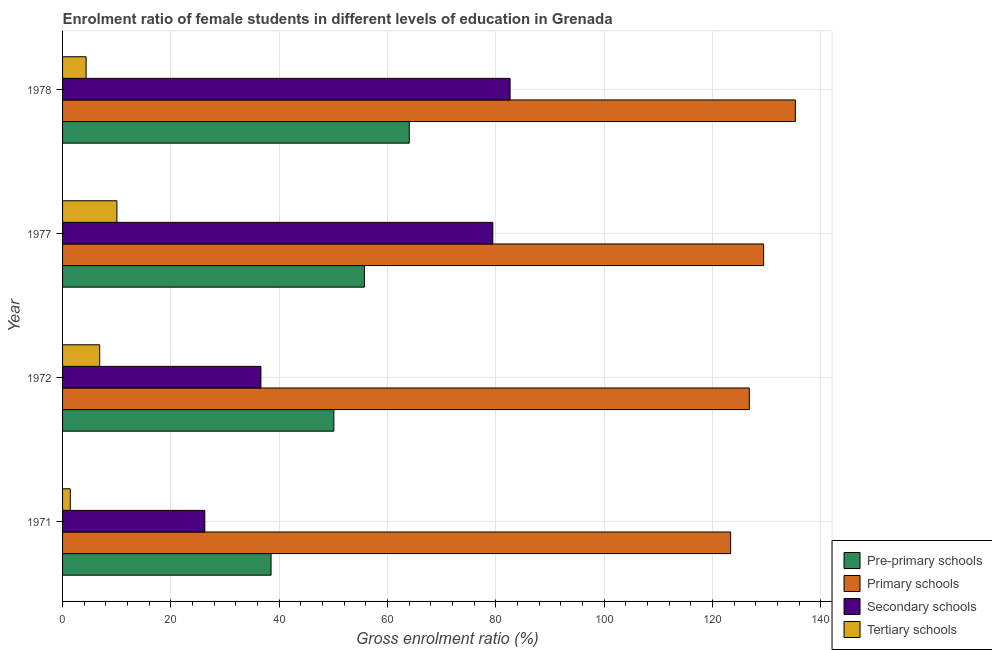How many different coloured bars are there?
Offer a terse response. 4. Are the number of bars per tick equal to the number of legend labels?
Offer a very short reply. Yes. What is the label of the 1st group of bars from the top?
Provide a short and direct response. 1978. In how many cases, is the number of bars for a given year not equal to the number of legend labels?
Offer a very short reply. 0. What is the gross enrolment ratio(male) in secondary schools in 1972?
Offer a terse response. 36.63. Across all years, what is the maximum gross enrolment ratio(male) in secondary schools?
Keep it short and to the point. 82.64. Across all years, what is the minimum gross enrolment ratio(male) in primary schools?
Give a very brief answer. 123.36. In which year was the gross enrolment ratio(male) in secondary schools maximum?
Provide a succinct answer. 1978. What is the total gross enrolment ratio(male) in secondary schools in the graph?
Your response must be concise. 224.98. What is the difference between the gross enrolment ratio(male) in tertiary schools in 1971 and that in 1977?
Give a very brief answer. -8.61. What is the difference between the gross enrolment ratio(male) in primary schools in 1971 and the gross enrolment ratio(male) in secondary schools in 1977?
Your answer should be compact. 43.92. What is the average gross enrolment ratio(male) in tertiary schools per year?
Your answer should be very brief. 5.67. In the year 1977, what is the difference between the gross enrolment ratio(male) in secondary schools and gross enrolment ratio(male) in pre-primary schools?
Make the answer very short. 23.71. In how many years, is the gross enrolment ratio(male) in tertiary schools greater than 116 %?
Offer a very short reply. 0. What is the ratio of the gross enrolment ratio(male) in pre-primary schools in 1972 to that in 1978?
Your answer should be very brief. 0.78. Is the gross enrolment ratio(male) in pre-primary schools in 1977 less than that in 1978?
Provide a short and direct response. Yes. What is the difference between the highest and the second highest gross enrolment ratio(male) in secondary schools?
Provide a short and direct response. 3.19. What is the difference between the highest and the lowest gross enrolment ratio(male) in secondary schools?
Make the answer very short. 56.37. What does the 2nd bar from the top in 1978 represents?
Offer a terse response. Secondary schools. What does the 2nd bar from the bottom in 1978 represents?
Give a very brief answer. Primary schools. Is it the case that in every year, the sum of the gross enrolment ratio(male) in pre-primary schools and gross enrolment ratio(male) in primary schools is greater than the gross enrolment ratio(male) in secondary schools?
Your answer should be compact. Yes. How many bars are there?
Provide a short and direct response. 16. Are all the bars in the graph horizontal?
Provide a short and direct response. Yes. How many years are there in the graph?
Provide a succinct answer. 4. Does the graph contain grids?
Offer a terse response. Yes. Where does the legend appear in the graph?
Give a very brief answer. Bottom right. How are the legend labels stacked?
Provide a short and direct response. Vertical. What is the title of the graph?
Your answer should be compact. Enrolment ratio of female students in different levels of education in Grenada. Does "Mammal species" appear as one of the legend labels in the graph?
Ensure brevity in your answer.  No. What is the Gross enrolment ratio (%) in Pre-primary schools in 1971?
Provide a succinct answer. 38.5. What is the Gross enrolment ratio (%) of Primary schools in 1971?
Offer a terse response. 123.36. What is the Gross enrolment ratio (%) in Secondary schools in 1971?
Your answer should be very brief. 26.27. What is the Gross enrolment ratio (%) in Tertiary schools in 1971?
Your answer should be compact. 1.42. What is the Gross enrolment ratio (%) in Pre-primary schools in 1972?
Your response must be concise. 50.09. What is the Gross enrolment ratio (%) of Primary schools in 1972?
Your answer should be very brief. 126.81. What is the Gross enrolment ratio (%) of Secondary schools in 1972?
Give a very brief answer. 36.63. What is the Gross enrolment ratio (%) in Tertiary schools in 1972?
Offer a very short reply. 6.85. What is the Gross enrolment ratio (%) of Pre-primary schools in 1977?
Your answer should be compact. 55.73. What is the Gross enrolment ratio (%) of Primary schools in 1977?
Your answer should be very brief. 129.45. What is the Gross enrolment ratio (%) of Secondary schools in 1977?
Keep it short and to the point. 79.45. What is the Gross enrolment ratio (%) of Tertiary schools in 1977?
Provide a succinct answer. 10.03. What is the Gross enrolment ratio (%) in Pre-primary schools in 1978?
Your answer should be very brief. 64.02. What is the Gross enrolment ratio (%) in Primary schools in 1978?
Keep it short and to the point. 135.32. What is the Gross enrolment ratio (%) of Secondary schools in 1978?
Provide a short and direct response. 82.64. What is the Gross enrolment ratio (%) in Tertiary schools in 1978?
Make the answer very short. 4.35. Across all years, what is the maximum Gross enrolment ratio (%) in Pre-primary schools?
Your response must be concise. 64.02. Across all years, what is the maximum Gross enrolment ratio (%) in Primary schools?
Offer a very short reply. 135.32. Across all years, what is the maximum Gross enrolment ratio (%) in Secondary schools?
Give a very brief answer. 82.64. Across all years, what is the maximum Gross enrolment ratio (%) in Tertiary schools?
Provide a short and direct response. 10.03. Across all years, what is the minimum Gross enrolment ratio (%) in Pre-primary schools?
Provide a short and direct response. 38.5. Across all years, what is the minimum Gross enrolment ratio (%) of Primary schools?
Your response must be concise. 123.36. Across all years, what is the minimum Gross enrolment ratio (%) of Secondary schools?
Your answer should be very brief. 26.27. Across all years, what is the minimum Gross enrolment ratio (%) in Tertiary schools?
Your response must be concise. 1.42. What is the total Gross enrolment ratio (%) of Pre-primary schools in the graph?
Ensure brevity in your answer.  208.35. What is the total Gross enrolment ratio (%) in Primary schools in the graph?
Ensure brevity in your answer.  514.95. What is the total Gross enrolment ratio (%) in Secondary schools in the graph?
Your response must be concise. 224.98. What is the total Gross enrolment ratio (%) of Tertiary schools in the graph?
Give a very brief answer. 22.66. What is the difference between the Gross enrolment ratio (%) of Pre-primary schools in 1971 and that in 1972?
Ensure brevity in your answer.  -11.59. What is the difference between the Gross enrolment ratio (%) of Primary schools in 1971 and that in 1972?
Ensure brevity in your answer.  -3.45. What is the difference between the Gross enrolment ratio (%) of Secondary schools in 1971 and that in 1972?
Your answer should be compact. -10.36. What is the difference between the Gross enrolment ratio (%) in Tertiary schools in 1971 and that in 1972?
Offer a terse response. -5.43. What is the difference between the Gross enrolment ratio (%) of Pre-primary schools in 1971 and that in 1977?
Offer a terse response. -17.23. What is the difference between the Gross enrolment ratio (%) of Primary schools in 1971 and that in 1977?
Keep it short and to the point. -6.09. What is the difference between the Gross enrolment ratio (%) of Secondary schools in 1971 and that in 1977?
Make the answer very short. -53.18. What is the difference between the Gross enrolment ratio (%) of Tertiary schools in 1971 and that in 1977?
Offer a terse response. -8.61. What is the difference between the Gross enrolment ratio (%) in Pre-primary schools in 1971 and that in 1978?
Ensure brevity in your answer.  -25.52. What is the difference between the Gross enrolment ratio (%) in Primary schools in 1971 and that in 1978?
Provide a short and direct response. -11.96. What is the difference between the Gross enrolment ratio (%) of Secondary schools in 1971 and that in 1978?
Offer a terse response. -56.37. What is the difference between the Gross enrolment ratio (%) in Tertiary schools in 1971 and that in 1978?
Provide a succinct answer. -2.92. What is the difference between the Gross enrolment ratio (%) in Pre-primary schools in 1972 and that in 1977?
Your answer should be very brief. -5.64. What is the difference between the Gross enrolment ratio (%) of Primary schools in 1972 and that in 1977?
Your answer should be very brief. -2.64. What is the difference between the Gross enrolment ratio (%) of Secondary schools in 1972 and that in 1977?
Offer a very short reply. -42.82. What is the difference between the Gross enrolment ratio (%) in Tertiary schools in 1972 and that in 1977?
Keep it short and to the point. -3.18. What is the difference between the Gross enrolment ratio (%) in Pre-primary schools in 1972 and that in 1978?
Make the answer very short. -13.93. What is the difference between the Gross enrolment ratio (%) in Primary schools in 1972 and that in 1978?
Your response must be concise. -8.51. What is the difference between the Gross enrolment ratio (%) of Secondary schools in 1972 and that in 1978?
Keep it short and to the point. -46.01. What is the difference between the Gross enrolment ratio (%) in Tertiary schools in 1972 and that in 1978?
Ensure brevity in your answer.  2.51. What is the difference between the Gross enrolment ratio (%) of Pre-primary schools in 1977 and that in 1978?
Keep it short and to the point. -8.29. What is the difference between the Gross enrolment ratio (%) in Primary schools in 1977 and that in 1978?
Provide a succinct answer. -5.87. What is the difference between the Gross enrolment ratio (%) of Secondary schools in 1977 and that in 1978?
Keep it short and to the point. -3.19. What is the difference between the Gross enrolment ratio (%) of Tertiary schools in 1977 and that in 1978?
Offer a terse response. 5.69. What is the difference between the Gross enrolment ratio (%) of Pre-primary schools in 1971 and the Gross enrolment ratio (%) of Primary schools in 1972?
Provide a succinct answer. -88.31. What is the difference between the Gross enrolment ratio (%) in Pre-primary schools in 1971 and the Gross enrolment ratio (%) in Secondary schools in 1972?
Your answer should be very brief. 1.87. What is the difference between the Gross enrolment ratio (%) in Pre-primary schools in 1971 and the Gross enrolment ratio (%) in Tertiary schools in 1972?
Your answer should be compact. 31.65. What is the difference between the Gross enrolment ratio (%) of Primary schools in 1971 and the Gross enrolment ratio (%) of Secondary schools in 1972?
Ensure brevity in your answer.  86.74. What is the difference between the Gross enrolment ratio (%) in Primary schools in 1971 and the Gross enrolment ratio (%) in Tertiary schools in 1972?
Your answer should be compact. 116.51. What is the difference between the Gross enrolment ratio (%) in Secondary schools in 1971 and the Gross enrolment ratio (%) in Tertiary schools in 1972?
Your answer should be compact. 19.41. What is the difference between the Gross enrolment ratio (%) in Pre-primary schools in 1971 and the Gross enrolment ratio (%) in Primary schools in 1977?
Offer a terse response. -90.95. What is the difference between the Gross enrolment ratio (%) in Pre-primary schools in 1971 and the Gross enrolment ratio (%) in Secondary schools in 1977?
Your response must be concise. -40.95. What is the difference between the Gross enrolment ratio (%) in Pre-primary schools in 1971 and the Gross enrolment ratio (%) in Tertiary schools in 1977?
Make the answer very short. 28.47. What is the difference between the Gross enrolment ratio (%) in Primary schools in 1971 and the Gross enrolment ratio (%) in Secondary schools in 1977?
Offer a very short reply. 43.92. What is the difference between the Gross enrolment ratio (%) of Primary schools in 1971 and the Gross enrolment ratio (%) of Tertiary schools in 1977?
Your response must be concise. 113.33. What is the difference between the Gross enrolment ratio (%) of Secondary schools in 1971 and the Gross enrolment ratio (%) of Tertiary schools in 1977?
Provide a short and direct response. 16.23. What is the difference between the Gross enrolment ratio (%) in Pre-primary schools in 1971 and the Gross enrolment ratio (%) in Primary schools in 1978?
Keep it short and to the point. -96.82. What is the difference between the Gross enrolment ratio (%) in Pre-primary schools in 1971 and the Gross enrolment ratio (%) in Secondary schools in 1978?
Your answer should be very brief. -44.14. What is the difference between the Gross enrolment ratio (%) in Pre-primary schools in 1971 and the Gross enrolment ratio (%) in Tertiary schools in 1978?
Ensure brevity in your answer.  34.15. What is the difference between the Gross enrolment ratio (%) in Primary schools in 1971 and the Gross enrolment ratio (%) in Secondary schools in 1978?
Ensure brevity in your answer.  40.73. What is the difference between the Gross enrolment ratio (%) of Primary schools in 1971 and the Gross enrolment ratio (%) of Tertiary schools in 1978?
Your answer should be compact. 119.02. What is the difference between the Gross enrolment ratio (%) in Secondary schools in 1971 and the Gross enrolment ratio (%) in Tertiary schools in 1978?
Your answer should be compact. 21.92. What is the difference between the Gross enrolment ratio (%) in Pre-primary schools in 1972 and the Gross enrolment ratio (%) in Primary schools in 1977?
Your answer should be very brief. -79.36. What is the difference between the Gross enrolment ratio (%) in Pre-primary schools in 1972 and the Gross enrolment ratio (%) in Secondary schools in 1977?
Provide a short and direct response. -29.35. What is the difference between the Gross enrolment ratio (%) in Pre-primary schools in 1972 and the Gross enrolment ratio (%) in Tertiary schools in 1977?
Offer a terse response. 40.06. What is the difference between the Gross enrolment ratio (%) in Primary schools in 1972 and the Gross enrolment ratio (%) in Secondary schools in 1977?
Your answer should be compact. 47.36. What is the difference between the Gross enrolment ratio (%) in Primary schools in 1972 and the Gross enrolment ratio (%) in Tertiary schools in 1977?
Provide a short and direct response. 116.78. What is the difference between the Gross enrolment ratio (%) in Secondary schools in 1972 and the Gross enrolment ratio (%) in Tertiary schools in 1977?
Offer a very short reply. 26.59. What is the difference between the Gross enrolment ratio (%) of Pre-primary schools in 1972 and the Gross enrolment ratio (%) of Primary schools in 1978?
Provide a short and direct response. -85.23. What is the difference between the Gross enrolment ratio (%) of Pre-primary schools in 1972 and the Gross enrolment ratio (%) of Secondary schools in 1978?
Offer a terse response. -32.54. What is the difference between the Gross enrolment ratio (%) in Pre-primary schools in 1972 and the Gross enrolment ratio (%) in Tertiary schools in 1978?
Offer a terse response. 45.75. What is the difference between the Gross enrolment ratio (%) in Primary schools in 1972 and the Gross enrolment ratio (%) in Secondary schools in 1978?
Offer a terse response. 44.17. What is the difference between the Gross enrolment ratio (%) of Primary schools in 1972 and the Gross enrolment ratio (%) of Tertiary schools in 1978?
Make the answer very short. 122.47. What is the difference between the Gross enrolment ratio (%) of Secondary schools in 1972 and the Gross enrolment ratio (%) of Tertiary schools in 1978?
Provide a short and direct response. 32.28. What is the difference between the Gross enrolment ratio (%) of Pre-primary schools in 1977 and the Gross enrolment ratio (%) of Primary schools in 1978?
Keep it short and to the point. -79.59. What is the difference between the Gross enrolment ratio (%) of Pre-primary schools in 1977 and the Gross enrolment ratio (%) of Secondary schools in 1978?
Make the answer very short. -26.91. What is the difference between the Gross enrolment ratio (%) in Pre-primary schools in 1977 and the Gross enrolment ratio (%) in Tertiary schools in 1978?
Your answer should be very brief. 51.39. What is the difference between the Gross enrolment ratio (%) in Primary schools in 1977 and the Gross enrolment ratio (%) in Secondary schools in 1978?
Your answer should be compact. 46.82. What is the difference between the Gross enrolment ratio (%) of Primary schools in 1977 and the Gross enrolment ratio (%) of Tertiary schools in 1978?
Offer a very short reply. 125.11. What is the difference between the Gross enrolment ratio (%) of Secondary schools in 1977 and the Gross enrolment ratio (%) of Tertiary schools in 1978?
Keep it short and to the point. 75.1. What is the average Gross enrolment ratio (%) in Pre-primary schools per year?
Provide a succinct answer. 52.09. What is the average Gross enrolment ratio (%) in Primary schools per year?
Give a very brief answer. 128.74. What is the average Gross enrolment ratio (%) of Secondary schools per year?
Provide a succinct answer. 56.24. What is the average Gross enrolment ratio (%) in Tertiary schools per year?
Offer a terse response. 5.66. In the year 1971, what is the difference between the Gross enrolment ratio (%) in Pre-primary schools and Gross enrolment ratio (%) in Primary schools?
Your answer should be very brief. -84.86. In the year 1971, what is the difference between the Gross enrolment ratio (%) of Pre-primary schools and Gross enrolment ratio (%) of Secondary schools?
Your answer should be very brief. 12.24. In the year 1971, what is the difference between the Gross enrolment ratio (%) of Pre-primary schools and Gross enrolment ratio (%) of Tertiary schools?
Offer a terse response. 37.08. In the year 1971, what is the difference between the Gross enrolment ratio (%) of Primary schools and Gross enrolment ratio (%) of Secondary schools?
Your answer should be very brief. 97.1. In the year 1971, what is the difference between the Gross enrolment ratio (%) in Primary schools and Gross enrolment ratio (%) in Tertiary schools?
Ensure brevity in your answer.  121.94. In the year 1971, what is the difference between the Gross enrolment ratio (%) of Secondary schools and Gross enrolment ratio (%) of Tertiary schools?
Keep it short and to the point. 24.84. In the year 1972, what is the difference between the Gross enrolment ratio (%) in Pre-primary schools and Gross enrolment ratio (%) in Primary schools?
Provide a short and direct response. -76.72. In the year 1972, what is the difference between the Gross enrolment ratio (%) in Pre-primary schools and Gross enrolment ratio (%) in Secondary schools?
Your answer should be compact. 13.47. In the year 1972, what is the difference between the Gross enrolment ratio (%) of Pre-primary schools and Gross enrolment ratio (%) of Tertiary schools?
Make the answer very short. 43.24. In the year 1972, what is the difference between the Gross enrolment ratio (%) of Primary schools and Gross enrolment ratio (%) of Secondary schools?
Your answer should be compact. 90.19. In the year 1972, what is the difference between the Gross enrolment ratio (%) of Primary schools and Gross enrolment ratio (%) of Tertiary schools?
Make the answer very short. 119.96. In the year 1972, what is the difference between the Gross enrolment ratio (%) of Secondary schools and Gross enrolment ratio (%) of Tertiary schools?
Keep it short and to the point. 29.77. In the year 1977, what is the difference between the Gross enrolment ratio (%) of Pre-primary schools and Gross enrolment ratio (%) of Primary schools?
Your answer should be compact. -73.72. In the year 1977, what is the difference between the Gross enrolment ratio (%) of Pre-primary schools and Gross enrolment ratio (%) of Secondary schools?
Provide a short and direct response. -23.72. In the year 1977, what is the difference between the Gross enrolment ratio (%) in Pre-primary schools and Gross enrolment ratio (%) in Tertiary schools?
Offer a very short reply. 45.7. In the year 1977, what is the difference between the Gross enrolment ratio (%) in Primary schools and Gross enrolment ratio (%) in Secondary schools?
Your answer should be compact. 50.01. In the year 1977, what is the difference between the Gross enrolment ratio (%) in Primary schools and Gross enrolment ratio (%) in Tertiary schools?
Provide a short and direct response. 119.42. In the year 1977, what is the difference between the Gross enrolment ratio (%) of Secondary schools and Gross enrolment ratio (%) of Tertiary schools?
Offer a terse response. 69.41. In the year 1978, what is the difference between the Gross enrolment ratio (%) of Pre-primary schools and Gross enrolment ratio (%) of Primary schools?
Give a very brief answer. -71.3. In the year 1978, what is the difference between the Gross enrolment ratio (%) in Pre-primary schools and Gross enrolment ratio (%) in Secondary schools?
Make the answer very short. -18.62. In the year 1978, what is the difference between the Gross enrolment ratio (%) in Pre-primary schools and Gross enrolment ratio (%) in Tertiary schools?
Your answer should be compact. 59.67. In the year 1978, what is the difference between the Gross enrolment ratio (%) in Primary schools and Gross enrolment ratio (%) in Secondary schools?
Give a very brief answer. 52.68. In the year 1978, what is the difference between the Gross enrolment ratio (%) in Primary schools and Gross enrolment ratio (%) in Tertiary schools?
Your answer should be compact. 130.97. In the year 1978, what is the difference between the Gross enrolment ratio (%) of Secondary schools and Gross enrolment ratio (%) of Tertiary schools?
Provide a succinct answer. 78.29. What is the ratio of the Gross enrolment ratio (%) in Pre-primary schools in 1971 to that in 1972?
Offer a terse response. 0.77. What is the ratio of the Gross enrolment ratio (%) of Primary schools in 1971 to that in 1972?
Ensure brevity in your answer.  0.97. What is the ratio of the Gross enrolment ratio (%) of Secondary schools in 1971 to that in 1972?
Your response must be concise. 0.72. What is the ratio of the Gross enrolment ratio (%) in Tertiary schools in 1971 to that in 1972?
Make the answer very short. 0.21. What is the ratio of the Gross enrolment ratio (%) in Pre-primary schools in 1971 to that in 1977?
Keep it short and to the point. 0.69. What is the ratio of the Gross enrolment ratio (%) of Primary schools in 1971 to that in 1977?
Provide a short and direct response. 0.95. What is the ratio of the Gross enrolment ratio (%) in Secondary schools in 1971 to that in 1977?
Your answer should be compact. 0.33. What is the ratio of the Gross enrolment ratio (%) in Tertiary schools in 1971 to that in 1977?
Provide a succinct answer. 0.14. What is the ratio of the Gross enrolment ratio (%) in Pre-primary schools in 1971 to that in 1978?
Offer a terse response. 0.6. What is the ratio of the Gross enrolment ratio (%) of Primary schools in 1971 to that in 1978?
Offer a terse response. 0.91. What is the ratio of the Gross enrolment ratio (%) in Secondary schools in 1971 to that in 1978?
Keep it short and to the point. 0.32. What is the ratio of the Gross enrolment ratio (%) of Tertiary schools in 1971 to that in 1978?
Make the answer very short. 0.33. What is the ratio of the Gross enrolment ratio (%) in Pre-primary schools in 1972 to that in 1977?
Provide a short and direct response. 0.9. What is the ratio of the Gross enrolment ratio (%) in Primary schools in 1972 to that in 1977?
Your answer should be very brief. 0.98. What is the ratio of the Gross enrolment ratio (%) in Secondary schools in 1972 to that in 1977?
Offer a terse response. 0.46. What is the ratio of the Gross enrolment ratio (%) of Tertiary schools in 1972 to that in 1977?
Your response must be concise. 0.68. What is the ratio of the Gross enrolment ratio (%) in Pre-primary schools in 1972 to that in 1978?
Ensure brevity in your answer.  0.78. What is the ratio of the Gross enrolment ratio (%) in Primary schools in 1972 to that in 1978?
Keep it short and to the point. 0.94. What is the ratio of the Gross enrolment ratio (%) of Secondary schools in 1972 to that in 1978?
Keep it short and to the point. 0.44. What is the ratio of the Gross enrolment ratio (%) of Tertiary schools in 1972 to that in 1978?
Offer a terse response. 1.58. What is the ratio of the Gross enrolment ratio (%) in Pre-primary schools in 1977 to that in 1978?
Offer a very short reply. 0.87. What is the ratio of the Gross enrolment ratio (%) in Primary schools in 1977 to that in 1978?
Provide a succinct answer. 0.96. What is the ratio of the Gross enrolment ratio (%) of Secondary schools in 1977 to that in 1978?
Your response must be concise. 0.96. What is the ratio of the Gross enrolment ratio (%) of Tertiary schools in 1977 to that in 1978?
Keep it short and to the point. 2.31. What is the difference between the highest and the second highest Gross enrolment ratio (%) of Pre-primary schools?
Your answer should be very brief. 8.29. What is the difference between the highest and the second highest Gross enrolment ratio (%) of Primary schools?
Make the answer very short. 5.87. What is the difference between the highest and the second highest Gross enrolment ratio (%) in Secondary schools?
Your answer should be compact. 3.19. What is the difference between the highest and the second highest Gross enrolment ratio (%) of Tertiary schools?
Provide a short and direct response. 3.18. What is the difference between the highest and the lowest Gross enrolment ratio (%) of Pre-primary schools?
Keep it short and to the point. 25.52. What is the difference between the highest and the lowest Gross enrolment ratio (%) of Primary schools?
Offer a terse response. 11.96. What is the difference between the highest and the lowest Gross enrolment ratio (%) in Secondary schools?
Offer a terse response. 56.37. What is the difference between the highest and the lowest Gross enrolment ratio (%) in Tertiary schools?
Your answer should be very brief. 8.61. 